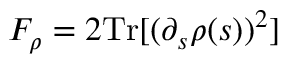<formula> <loc_0><loc_0><loc_500><loc_500>F _ { \rho } = 2 T r [ ( \partial _ { s } \rho ( s ) ) ^ { 2 } ]</formula> 